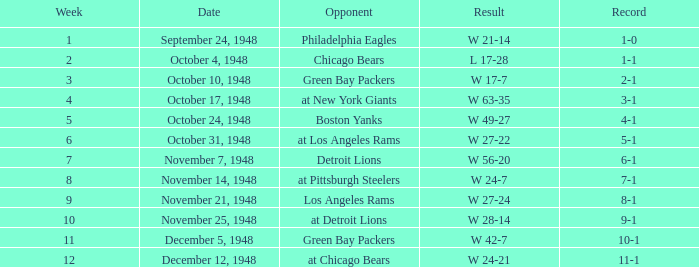What date was the opponent the Boston Yanks? October 24, 1948. 